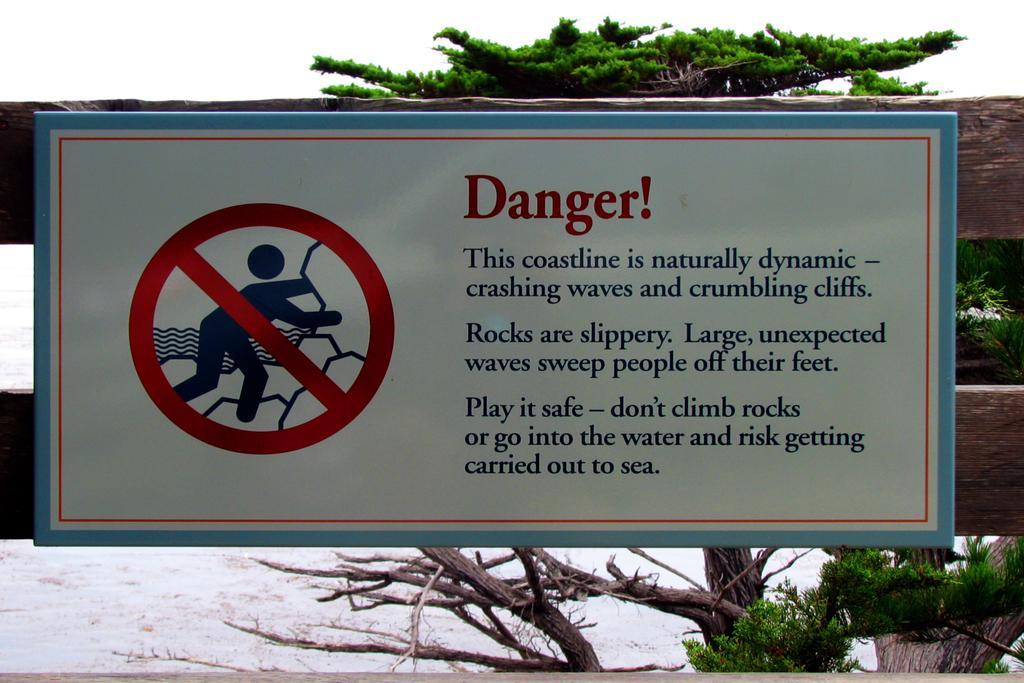Describe this image in one or two sentences. In this image I can see a white color board attached to some object and I can see something written on the board. Background I can see trees in green color and the sky is in white color. 